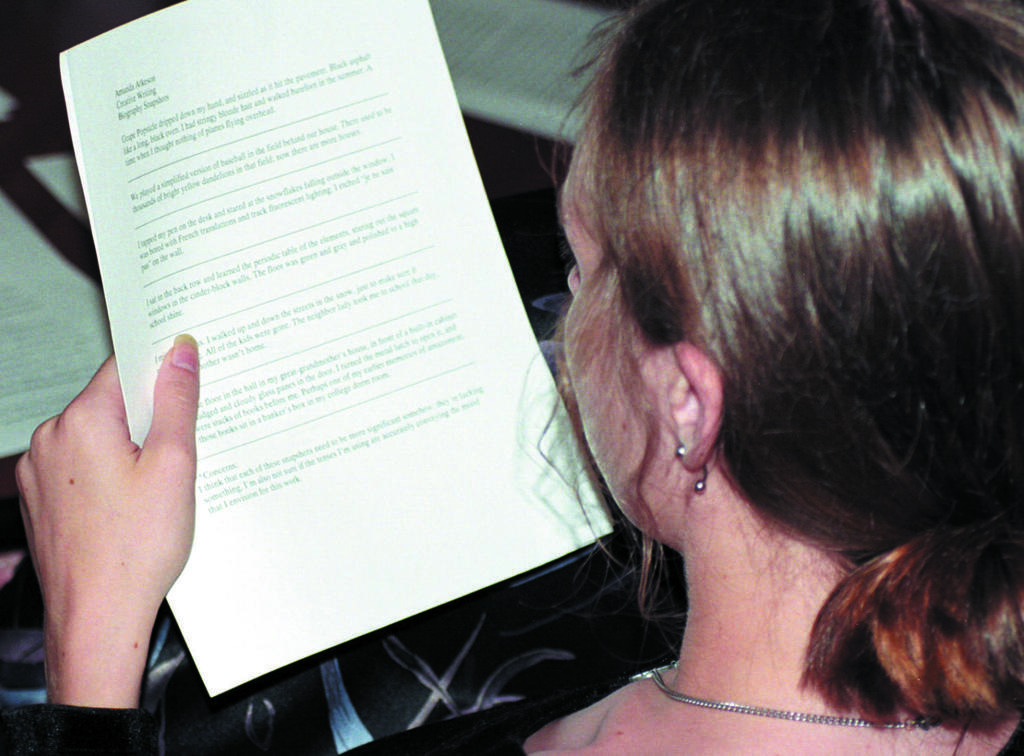What is the main subject of the image? The main subject of the image is a woman. What is the woman holding in the image? The woman is holding a paper. What type of clouds can be seen in the image? There are no clouds visible in the image, as it features a woman holding a paper. Is there a kitten playing with a bar of soap in the image? There is no kitten or soap present in the image. 